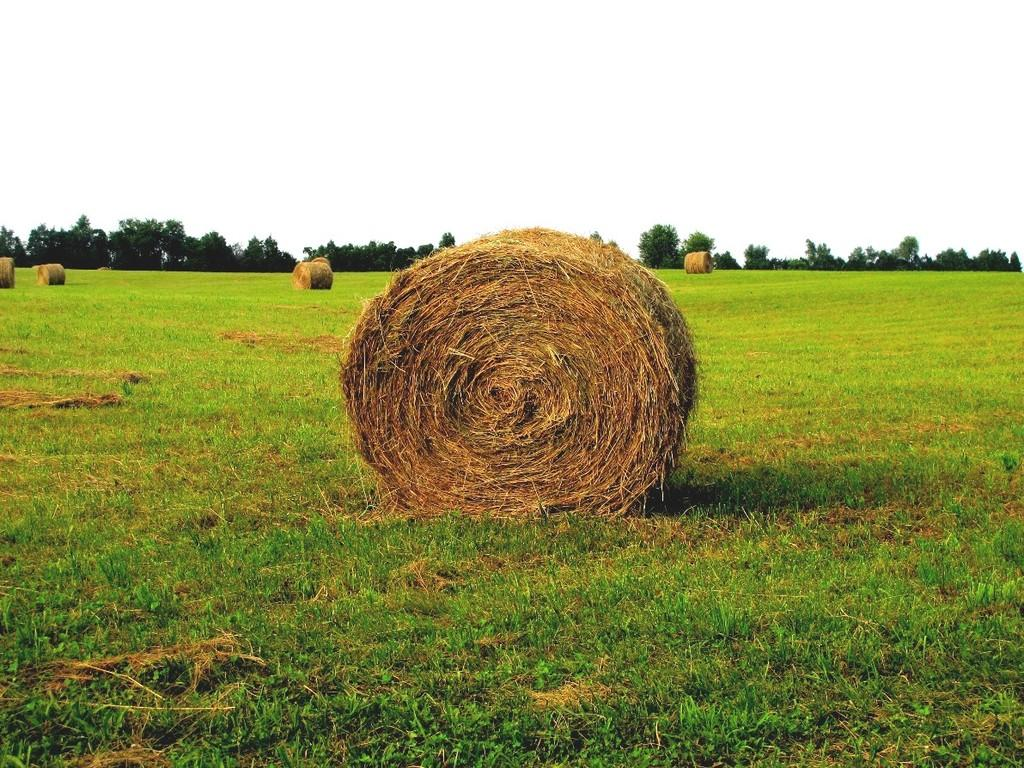What type of surface can be seen in the image? Ground is visible in the image. What type of vegetation is present in the image? There is grass in the image. What other natural elements can be seen in the image? There are trees in the image. What is visible in the background of the image? The sky is visible in the background of the image. What time does the clock in the image show? There is no clock present in the image. How does the noise level in the image affect the visibility of the grass? The image does not provide any information about the noise level, and the visibility of the grass is not affected by noise. 